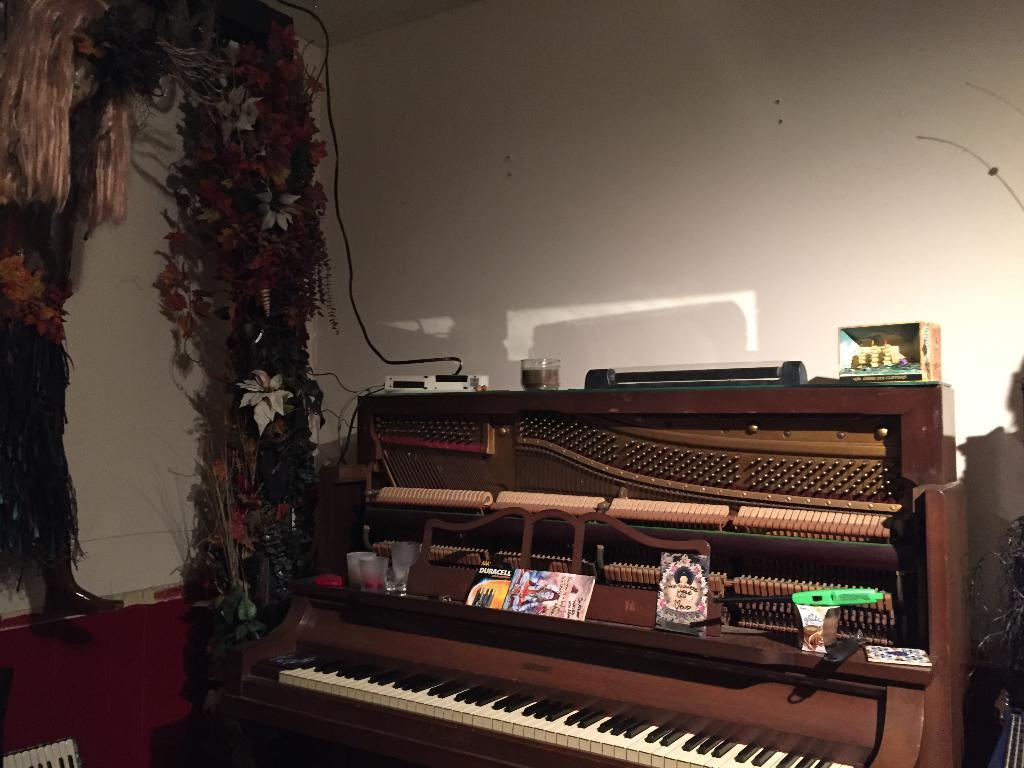What is the main object in the image? There is a piano in the image. Are there any items placed on the piano? Yes, there are objects on the piano. What type of decoration can be seen on the left side of the image? There are decorating flowers on the left side of the image. What is located in front of the piano? There is a wall in front of the piano. Can you see a yak playing the piano in the image? No, there is no yak present in the image, and it does not show any animals playing the piano. 